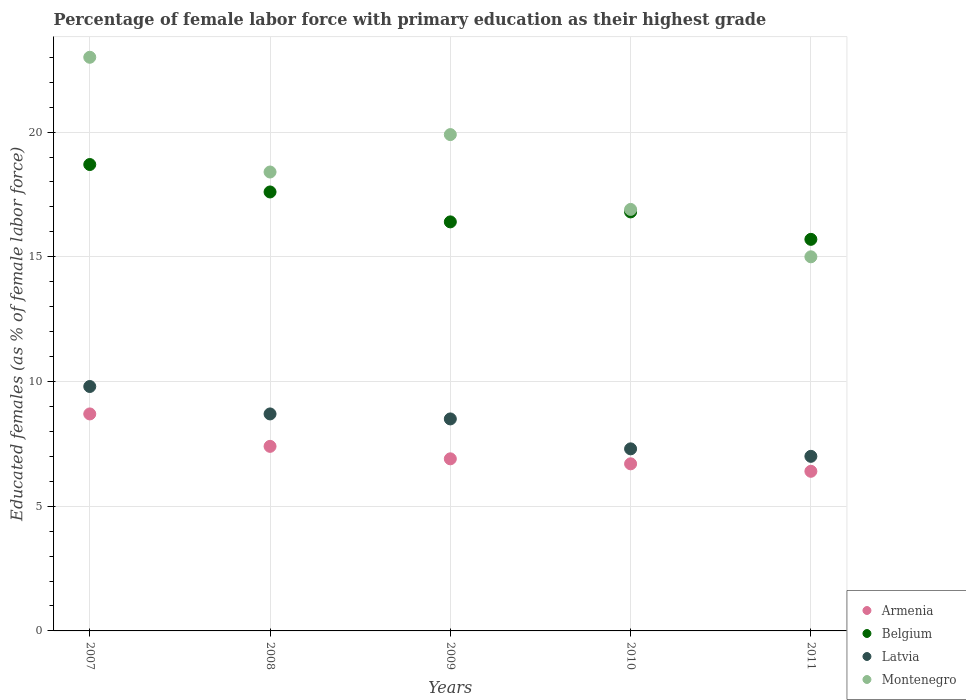How many different coloured dotlines are there?
Offer a terse response. 4. Is the number of dotlines equal to the number of legend labels?
Provide a short and direct response. Yes. What is the percentage of female labor force with primary education in Armenia in 2010?
Ensure brevity in your answer.  6.7. Across all years, what is the maximum percentage of female labor force with primary education in Armenia?
Offer a very short reply. 8.7. Across all years, what is the minimum percentage of female labor force with primary education in Latvia?
Your answer should be compact. 7. In which year was the percentage of female labor force with primary education in Armenia minimum?
Make the answer very short. 2011. What is the total percentage of female labor force with primary education in Montenegro in the graph?
Keep it short and to the point. 93.2. What is the difference between the percentage of female labor force with primary education in Latvia in 2010 and that in 2011?
Your response must be concise. 0.3. What is the difference between the percentage of female labor force with primary education in Latvia in 2009 and the percentage of female labor force with primary education in Armenia in 2008?
Your answer should be very brief. 1.1. What is the average percentage of female labor force with primary education in Montenegro per year?
Provide a short and direct response. 18.64. In the year 2011, what is the difference between the percentage of female labor force with primary education in Montenegro and percentage of female labor force with primary education in Armenia?
Offer a terse response. 8.6. What is the ratio of the percentage of female labor force with primary education in Montenegro in 2007 to that in 2010?
Ensure brevity in your answer.  1.36. Is the percentage of female labor force with primary education in Armenia in 2008 less than that in 2009?
Your answer should be compact. No. What is the difference between the highest and the second highest percentage of female labor force with primary education in Latvia?
Ensure brevity in your answer.  1.1. What is the difference between the highest and the lowest percentage of female labor force with primary education in Montenegro?
Make the answer very short. 8. Is the sum of the percentage of female labor force with primary education in Montenegro in 2008 and 2010 greater than the maximum percentage of female labor force with primary education in Belgium across all years?
Your answer should be very brief. Yes. Is it the case that in every year, the sum of the percentage of female labor force with primary education in Armenia and percentage of female labor force with primary education in Belgium  is greater than the sum of percentage of female labor force with primary education in Montenegro and percentage of female labor force with primary education in Latvia?
Keep it short and to the point. Yes. Is it the case that in every year, the sum of the percentage of female labor force with primary education in Latvia and percentage of female labor force with primary education in Armenia  is greater than the percentage of female labor force with primary education in Montenegro?
Provide a short and direct response. No. Is the percentage of female labor force with primary education in Montenegro strictly greater than the percentage of female labor force with primary education in Armenia over the years?
Your answer should be very brief. Yes. What is the difference between two consecutive major ticks on the Y-axis?
Give a very brief answer. 5. Does the graph contain grids?
Make the answer very short. Yes. How many legend labels are there?
Ensure brevity in your answer.  4. How are the legend labels stacked?
Keep it short and to the point. Vertical. What is the title of the graph?
Provide a succinct answer. Percentage of female labor force with primary education as their highest grade. Does "Trinidad and Tobago" appear as one of the legend labels in the graph?
Your answer should be very brief. No. What is the label or title of the Y-axis?
Your answer should be very brief. Educated females (as % of female labor force). What is the Educated females (as % of female labor force) of Armenia in 2007?
Your response must be concise. 8.7. What is the Educated females (as % of female labor force) in Belgium in 2007?
Ensure brevity in your answer.  18.7. What is the Educated females (as % of female labor force) of Latvia in 2007?
Ensure brevity in your answer.  9.8. What is the Educated females (as % of female labor force) in Armenia in 2008?
Provide a succinct answer. 7.4. What is the Educated females (as % of female labor force) in Belgium in 2008?
Ensure brevity in your answer.  17.6. What is the Educated females (as % of female labor force) of Latvia in 2008?
Keep it short and to the point. 8.7. What is the Educated females (as % of female labor force) of Montenegro in 2008?
Keep it short and to the point. 18.4. What is the Educated females (as % of female labor force) of Armenia in 2009?
Provide a succinct answer. 6.9. What is the Educated females (as % of female labor force) of Belgium in 2009?
Your answer should be very brief. 16.4. What is the Educated females (as % of female labor force) in Latvia in 2009?
Offer a very short reply. 8.5. What is the Educated females (as % of female labor force) of Montenegro in 2009?
Ensure brevity in your answer.  19.9. What is the Educated females (as % of female labor force) of Armenia in 2010?
Provide a succinct answer. 6.7. What is the Educated females (as % of female labor force) of Belgium in 2010?
Provide a short and direct response. 16.8. What is the Educated females (as % of female labor force) in Latvia in 2010?
Keep it short and to the point. 7.3. What is the Educated females (as % of female labor force) in Montenegro in 2010?
Ensure brevity in your answer.  16.9. What is the Educated females (as % of female labor force) in Armenia in 2011?
Ensure brevity in your answer.  6.4. What is the Educated females (as % of female labor force) of Belgium in 2011?
Ensure brevity in your answer.  15.7. Across all years, what is the maximum Educated females (as % of female labor force) in Armenia?
Offer a very short reply. 8.7. Across all years, what is the maximum Educated females (as % of female labor force) of Belgium?
Make the answer very short. 18.7. Across all years, what is the maximum Educated females (as % of female labor force) in Latvia?
Provide a succinct answer. 9.8. Across all years, what is the maximum Educated females (as % of female labor force) in Montenegro?
Offer a very short reply. 23. Across all years, what is the minimum Educated females (as % of female labor force) in Armenia?
Keep it short and to the point. 6.4. Across all years, what is the minimum Educated females (as % of female labor force) in Belgium?
Make the answer very short. 15.7. Across all years, what is the minimum Educated females (as % of female labor force) of Montenegro?
Give a very brief answer. 15. What is the total Educated females (as % of female labor force) in Armenia in the graph?
Your answer should be very brief. 36.1. What is the total Educated females (as % of female labor force) in Belgium in the graph?
Provide a succinct answer. 85.2. What is the total Educated females (as % of female labor force) in Latvia in the graph?
Ensure brevity in your answer.  41.3. What is the total Educated females (as % of female labor force) of Montenegro in the graph?
Your response must be concise. 93.2. What is the difference between the Educated females (as % of female labor force) of Armenia in 2007 and that in 2008?
Your response must be concise. 1.3. What is the difference between the Educated females (as % of female labor force) of Belgium in 2007 and that in 2008?
Ensure brevity in your answer.  1.1. What is the difference between the Educated females (as % of female labor force) in Latvia in 2007 and that in 2008?
Provide a succinct answer. 1.1. What is the difference between the Educated females (as % of female labor force) of Montenegro in 2007 and that in 2008?
Ensure brevity in your answer.  4.6. What is the difference between the Educated females (as % of female labor force) in Montenegro in 2007 and that in 2009?
Provide a succinct answer. 3.1. What is the difference between the Educated females (as % of female labor force) of Belgium in 2007 and that in 2010?
Provide a succinct answer. 1.9. What is the difference between the Educated females (as % of female labor force) of Montenegro in 2007 and that in 2011?
Make the answer very short. 8. What is the difference between the Educated females (as % of female labor force) of Belgium in 2008 and that in 2009?
Provide a succinct answer. 1.2. What is the difference between the Educated females (as % of female labor force) of Armenia in 2008 and that in 2010?
Provide a short and direct response. 0.7. What is the difference between the Educated females (as % of female labor force) in Montenegro in 2008 and that in 2010?
Offer a terse response. 1.5. What is the difference between the Educated females (as % of female labor force) in Armenia in 2008 and that in 2011?
Offer a very short reply. 1. What is the difference between the Educated females (as % of female labor force) of Belgium in 2008 and that in 2011?
Offer a very short reply. 1.9. What is the difference between the Educated females (as % of female labor force) in Montenegro in 2008 and that in 2011?
Provide a succinct answer. 3.4. What is the difference between the Educated females (as % of female labor force) of Armenia in 2009 and that in 2010?
Your answer should be compact. 0.2. What is the difference between the Educated females (as % of female labor force) of Latvia in 2009 and that in 2010?
Provide a succinct answer. 1.2. What is the difference between the Educated females (as % of female labor force) in Armenia in 2009 and that in 2011?
Ensure brevity in your answer.  0.5. What is the difference between the Educated females (as % of female labor force) of Belgium in 2009 and that in 2011?
Give a very brief answer. 0.7. What is the difference between the Educated females (as % of female labor force) of Armenia in 2010 and that in 2011?
Offer a very short reply. 0.3. What is the difference between the Educated females (as % of female labor force) in Latvia in 2010 and that in 2011?
Your answer should be very brief. 0.3. What is the difference between the Educated females (as % of female labor force) in Belgium in 2007 and the Educated females (as % of female labor force) in Montenegro in 2008?
Your answer should be very brief. 0.3. What is the difference between the Educated females (as % of female labor force) in Latvia in 2007 and the Educated females (as % of female labor force) in Montenegro in 2008?
Provide a short and direct response. -8.6. What is the difference between the Educated females (as % of female labor force) of Armenia in 2007 and the Educated females (as % of female labor force) of Belgium in 2009?
Offer a terse response. -7.7. What is the difference between the Educated females (as % of female labor force) of Armenia in 2007 and the Educated females (as % of female labor force) of Montenegro in 2009?
Make the answer very short. -11.2. What is the difference between the Educated females (as % of female labor force) in Belgium in 2007 and the Educated females (as % of female labor force) in Latvia in 2009?
Give a very brief answer. 10.2. What is the difference between the Educated females (as % of female labor force) of Armenia in 2007 and the Educated females (as % of female labor force) of Belgium in 2010?
Your answer should be very brief. -8.1. What is the difference between the Educated females (as % of female labor force) of Armenia in 2007 and the Educated females (as % of female labor force) of Montenegro in 2010?
Offer a very short reply. -8.2. What is the difference between the Educated females (as % of female labor force) of Latvia in 2007 and the Educated females (as % of female labor force) of Montenegro in 2010?
Give a very brief answer. -7.1. What is the difference between the Educated females (as % of female labor force) in Armenia in 2007 and the Educated females (as % of female labor force) in Belgium in 2011?
Offer a very short reply. -7. What is the difference between the Educated females (as % of female labor force) of Armenia in 2007 and the Educated females (as % of female labor force) of Latvia in 2011?
Make the answer very short. 1.7. What is the difference between the Educated females (as % of female labor force) of Latvia in 2007 and the Educated females (as % of female labor force) of Montenegro in 2011?
Your answer should be compact. -5.2. What is the difference between the Educated females (as % of female labor force) in Belgium in 2008 and the Educated females (as % of female labor force) in Latvia in 2009?
Your answer should be compact. 9.1. What is the difference between the Educated females (as % of female labor force) of Belgium in 2008 and the Educated females (as % of female labor force) of Montenegro in 2009?
Provide a short and direct response. -2.3. What is the difference between the Educated females (as % of female labor force) in Latvia in 2008 and the Educated females (as % of female labor force) in Montenegro in 2009?
Ensure brevity in your answer.  -11.2. What is the difference between the Educated females (as % of female labor force) of Armenia in 2008 and the Educated females (as % of female labor force) of Latvia in 2010?
Make the answer very short. 0.1. What is the difference between the Educated females (as % of female labor force) of Belgium in 2008 and the Educated females (as % of female labor force) of Latvia in 2010?
Offer a very short reply. 10.3. What is the difference between the Educated females (as % of female labor force) in Belgium in 2008 and the Educated females (as % of female labor force) in Montenegro in 2010?
Offer a very short reply. 0.7. What is the difference between the Educated females (as % of female labor force) of Armenia in 2008 and the Educated females (as % of female labor force) of Belgium in 2011?
Give a very brief answer. -8.3. What is the difference between the Educated females (as % of female labor force) in Armenia in 2008 and the Educated females (as % of female labor force) in Montenegro in 2011?
Your answer should be compact. -7.6. What is the difference between the Educated females (as % of female labor force) of Belgium in 2008 and the Educated females (as % of female labor force) of Latvia in 2011?
Provide a succinct answer. 10.6. What is the difference between the Educated females (as % of female labor force) in Latvia in 2008 and the Educated females (as % of female labor force) in Montenegro in 2011?
Your answer should be compact. -6.3. What is the difference between the Educated females (as % of female labor force) of Armenia in 2009 and the Educated females (as % of female labor force) of Latvia in 2010?
Offer a very short reply. -0.4. What is the difference between the Educated females (as % of female labor force) of Belgium in 2009 and the Educated females (as % of female labor force) of Latvia in 2010?
Give a very brief answer. 9.1. What is the difference between the Educated females (as % of female labor force) of Latvia in 2009 and the Educated females (as % of female labor force) of Montenegro in 2010?
Offer a very short reply. -8.4. What is the difference between the Educated females (as % of female labor force) of Armenia in 2009 and the Educated females (as % of female labor force) of Latvia in 2011?
Your answer should be very brief. -0.1. What is the difference between the Educated females (as % of female labor force) of Belgium in 2009 and the Educated females (as % of female labor force) of Montenegro in 2011?
Make the answer very short. 1.4. What is the difference between the Educated females (as % of female labor force) in Latvia in 2009 and the Educated females (as % of female labor force) in Montenegro in 2011?
Make the answer very short. -6.5. What is the difference between the Educated females (as % of female labor force) in Armenia in 2010 and the Educated females (as % of female labor force) in Belgium in 2011?
Provide a short and direct response. -9. What is the difference between the Educated females (as % of female labor force) in Armenia in 2010 and the Educated females (as % of female labor force) in Montenegro in 2011?
Ensure brevity in your answer.  -8.3. What is the difference between the Educated females (as % of female labor force) in Belgium in 2010 and the Educated females (as % of female labor force) in Latvia in 2011?
Your response must be concise. 9.8. What is the difference between the Educated females (as % of female labor force) in Belgium in 2010 and the Educated females (as % of female labor force) in Montenegro in 2011?
Your answer should be compact. 1.8. What is the difference between the Educated females (as % of female labor force) in Latvia in 2010 and the Educated females (as % of female labor force) in Montenegro in 2011?
Ensure brevity in your answer.  -7.7. What is the average Educated females (as % of female labor force) of Armenia per year?
Give a very brief answer. 7.22. What is the average Educated females (as % of female labor force) in Belgium per year?
Offer a very short reply. 17.04. What is the average Educated females (as % of female labor force) of Latvia per year?
Make the answer very short. 8.26. What is the average Educated females (as % of female labor force) in Montenegro per year?
Your answer should be very brief. 18.64. In the year 2007, what is the difference between the Educated females (as % of female labor force) in Armenia and Educated females (as % of female labor force) in Belgium?
Your answer should be very brief. -10. In the year 2007, what is the difference between the Educated females (as % of female labor force) of Armenia and Educated females (as % of female labor force) of Montenegro?
Your answer should be very brief. -14.3. In the year 2007, what is the difference between the Educated females (as % of female labor force) in Belgium and Educated females (as % of female labor force) in Latvia?
Your answer should be very brief. 8.9. In the year 2007, what is the difference between the Educated females (as % of female labor force) in Belgium and Educated females (as % of female labor force) in Montenegro?
Provide a succinct answer. -4.3. In the year 2007, what is the difference between the Educated females (as % of female labor force) of Latvia and Educated females (as % of female labor force) of Montenegro?
Ensure brevity in your answer.  -13.2. In the year 2008, what is the difference between the Educated females (as % of female labor force) in Armenia and Educated females (as % of female labor force) in Latvia?
Ensure brevity in your answer.  -1.3. In the year 2008, what is the difference between the Educated females (as % of female labor force) in Belgium and Educated females (as % of female labor force) in Latvia?
Ensure brevity in your answer.  8.9. In the year 2008, what is the difference between the Educated females (as % of female labor force) of Latvia and Educated females (as % of female labor force) of Montenegro?
Provide a short and direct response. -9.7. In the year 2009, what is the difference between the Educated females (as % of female labor force) in Armenia and Educated females (as % of female labor force) in Montenegro?
Offer a terse response. -13. In the year 2009, what is the difference between the Educated females (as % of female labor force) of Belgium and Educated females (as % of female labor force) of Latvia?
Your response must be concise. 7.9. In the year 2010, what is the difference between the Educated females (as % of female labor force) of Armenia and Educated females (as % of female labor force) of Latvia?
Your answer should be very brief. -0.6. In the year 2010, what is the difference between the Educated females (as % of female labor force) of Armenia and Educated females (as % of female labor force) of Montenegro?
Give a very brief answer. -10.2. In the year 2010, what is the difference between the Educated females (as % of female labor force) in Latvia and Educated females (as % of female labor force) in Montenegro?
Give a very brief answer. -9.6. In the year 2011, what is the difference between the Educated females (as % of female labor force) in Armenia and Educated females (as % of female labor force) in Belgium?
Keep it short and to the point. -9.3. In the year 2011, what is the difference between the Educated females (as % of female labor force) of Armenia and Educated females (as % of female labor force) of Montenegro?
Keep it short and to the point. -8.6. In the year 2011, what is the difference between the Educated females (as % of female labor force) in Latvia and Educated females (as % of female labor force) in Montenegro?
Your answer should be compact. -8. What is the ratio of the Educated females (as % of female labor force) of Armenia in 2007 to that in 2008?
Give a very brief answer. 1.18. What is the ratio of the Educated females (as % of female labor force) in Latvia in 2007 to that in 2008?
Your answer should be compact. 1.13. What is the ratio of the Educated females (as % of female labor force) in Armenia in 2007 to that in 2009?
Keep it short and to the point. 1.26. What is the ratio of the Educated females (as % of female labor force) in Belgium in 2007 to that in 2009?
Ensure brevity in your answer.  1.14. What is the ratio of the Educated females (as % of female labor force) in Latvia in 2007 to that in 2009?
Keep it short and to the point. 1.15. What is the ratio of the Educated females (as % of female labor force) in Montenegro in 2007 to that in 2009?
Offer a terse response. 1.16. What is the ratio of the Educated females (as % of female labor force) in Armenia in 2007 to that in 2010?
Offer a very short reply. 1.3. What is the ratio of the Educated females (as % of female labor force) of Belgium in 2007 to that in 2010?
Provide a short and direct response. 1.11. What is the ratio of the Educated females (as % of female labor force) in Latvia in 2007 to that in 2010?
Offer a very short reply. 1.34. What is the ratio of the Educated females (as % of female labor force) of Montenegro in 2007 to that in 2010?
Your response must be concise. 1.36. What is the ratio of the Educated females (as % of female labor force) in Armenia in 2007 to that in 2011?
Make the answer very short. 1.36. What is the ratio of the Educated females (as % of female labor force) in Belgium in 2007 to that in 2011?
Provide a short and direct response. 1.19. What is the ratio of the Educated females (as % of female labor force) in Montenegro in 2007 to that in 2011?
Make the answer very short. 1.53. What is the ratio of the Educated females (as % of female labor force) of Armenia in 2008 to that in 2009?
Make the answer very short. 1.07. What is the ratio of the Educated females (as % of female labor force) in Belgium in 2008 to that in 2009?
Keep it short and to the point. 1.07. What is the ratio of the Educated females (as % of female labor force) in Latvia in 2008 to that in 2009?
Your answer should be very brief. 1.02. What is the ratio of the Educated females (as % of female labor force) of Montenegro in 2008 to that in 2009?
Keep it short and to the point. 0.92. What is the ratio of the Educated females (as % of female labor force) in Armenia in 2008 to that in 2010?
Your answer should be very brief. 1.1. What is the ratio of the Educated females (as % of female labor force) in Belgium in 2008 to that in 2010?
Provide a succinct answer. 1.05. What is the ratio of the Educated females (as % of female labor force) in Latvia in 2008 to that in 2010?
Ensure brevity in your answer.  1.19. What is the ratio of the Educated females (as % of female labor force) of Montenegro in 2008 to that in 2010?
Keep it short and to the point. 1.09. What is the ratio of the Educated females (as % of female labor force) in Armenia in 2008 to that in 2011?
Ensure brevity in your answer.  1.16. What is the ratio of the Educated females (as % of female labor force) in Belgium in 2008 to that in 2011?
Ensure brevity in your answer.  1.12. What is the ratio of the Educated females (as % of female labor force) of Latvia in 2008 to that in 2011?
Your answer should be compact. 1.24. What is the ratio of the Educated females (as % of female labor force) of Montenegro in 2008 to that in 2011?
Ensure brevity in your answer.  1.23. What is the ratio of the Educated females (as % of female labor force) of Armenia in 2009 to that in 2010?
Your answer should be compact. 1.03. What is the ratio of the Educated females (as % of female labor force) of Belgium in 2009 to that in 2010?
Give a very brief answer. 0.98. What is the ratio of the Educated females (as % of female labor force) in Latvia in 2009 to that in 2010?
Give a very brief answer. 1.16. What is the ratio of the Educated females (as % of female labor force) in Montenegro in 2009 to that in 2010?
Your answer should be compact. 1.18. What is the ratio of the Educated females (as % of female labor force) of Armenia in 2009 to that in 2011?
Make the answer very short. 1.08. What is the ratio of the Educated females (as % of female labor force) of Belgium in 2009 to that in 2011?
Provide a short and direct response. 1.04. What is the ratio of the Educated females (as % of female labor force) of Latvia in 2009 to that in 2011?
Provide a short and direct response. 1.21. What is the ratio of the Educated females (as % of female labor force) in Montenegro in 2009 to that in 2011?
Provide a short and direct response. 1.33. What is the ratio of the Educated females (as % of female labor force) of Armenia in 2010 to that in 2011?
Keep it short and to the point. 1.05. What is the ratio of the Educated females (as % of female labor force) of Belgium in 2010 to that in 2011?
Make the answer very short. 1.07. What is the ratio of the Educated females (as % of female labor force) of Latvia in 2010 to that in 2011?
Your response must be concise. 1.04. What is the ratio of the Educated females (as % of female labor force) of Montenegro in 2010 to that in 2011?
Provide a succinct answer. 1.13. What is the difference between the highest and the second highest Educated females (as % of female labor force) of Latvia?
Your response must be concise. 1.1. What is the difference between the highest and the second highest Educated females (as % of female labor force) in Montenegro?
Your answer should be compact. 3.1. What is the difference between the highest and the lowest Educated females (as % of female labor force) in Latvia?
Ensure brevity in your answer.  2.8. 